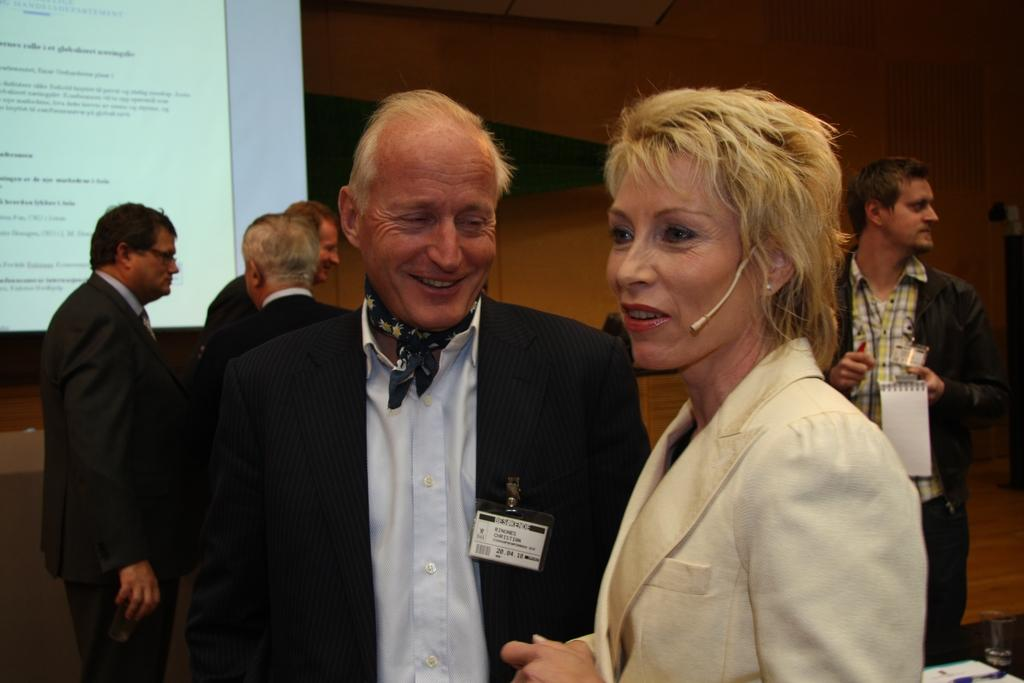What can be seen in the image? There are people standing in the image. Where are the people standing? The people are standing on a floor. What is visible in the background of the image? There is a wall and a screen in the background of the image. What is displayed on the screen? There is text visible on the screen. How do the people's legs affect the acoustics in the image? The people's legs do not affect the acoustics in the image, as the provided facts do not mention any sound or acoustics-related information. 